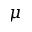Convert formula to latex. <formula><loc_0><loc_0><loc_500><loc_500>\mu</formula> 